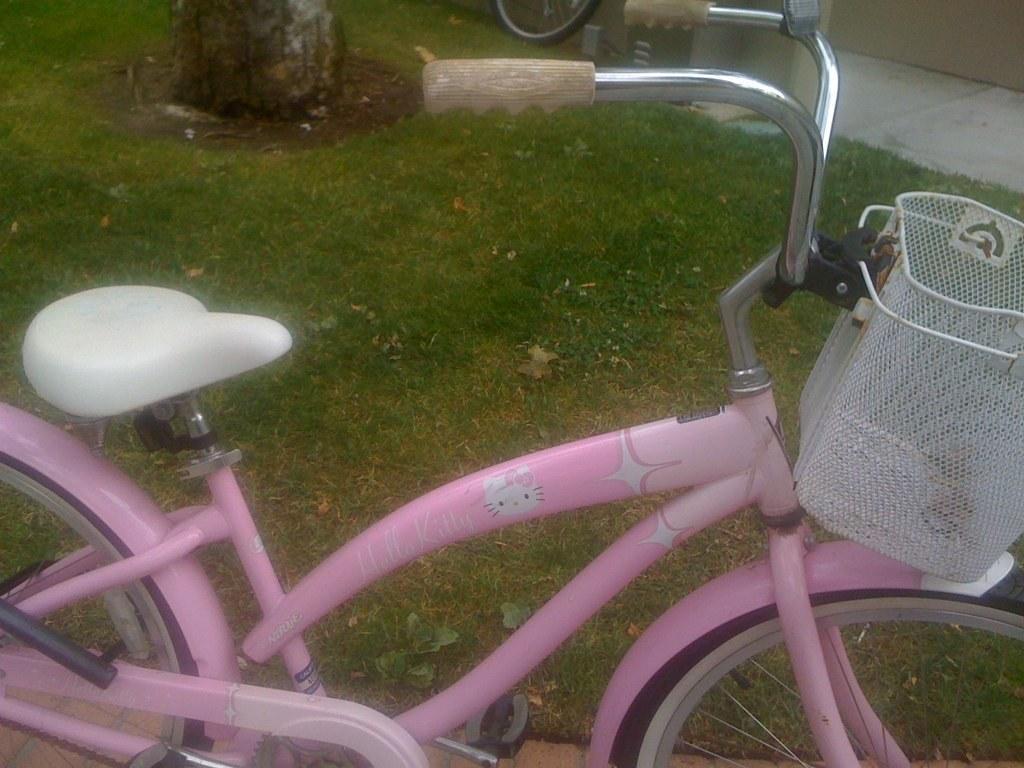Please provide a concise description of this image. In this image, we can see a bicycle which is colored pink. 